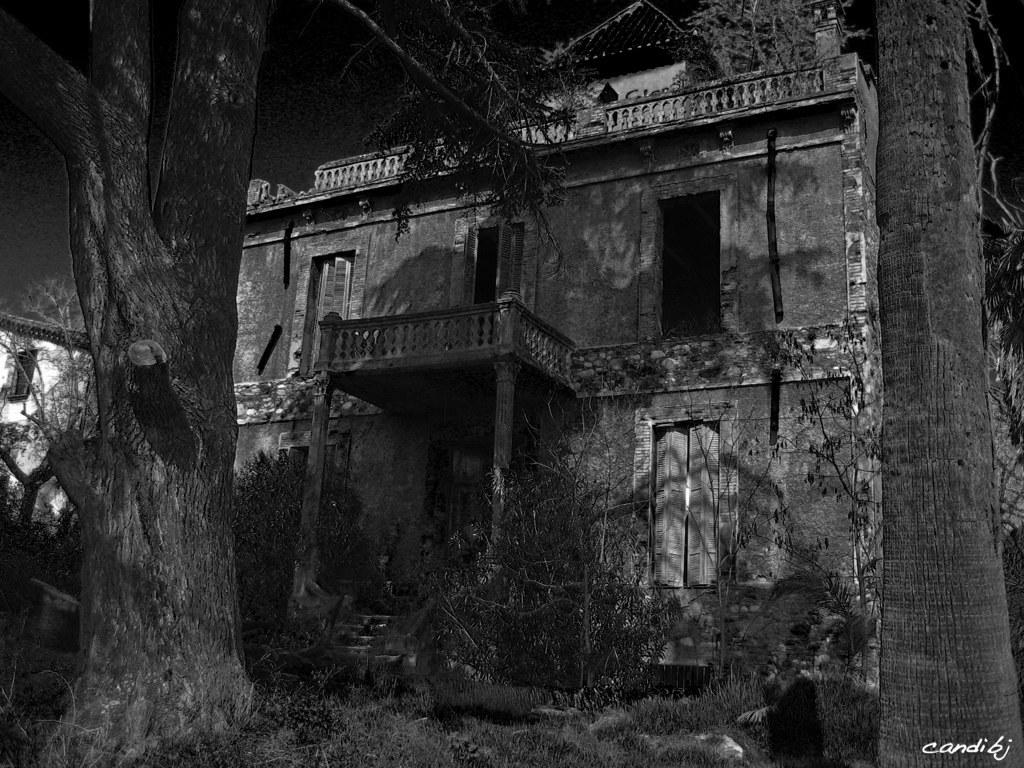What type of structure is visible in the image? There is a building in the image. What can be seen on the left side of the image? There are trees on the left side of the image. What is the color scheme of the image? The image is in black and white. What type of toy can be seen on the table during the feast in the image? There is no toy or feast present in the image; it features a building and trees. What type of soup is being served in the image? There is no soup or any food depicted in the image. 